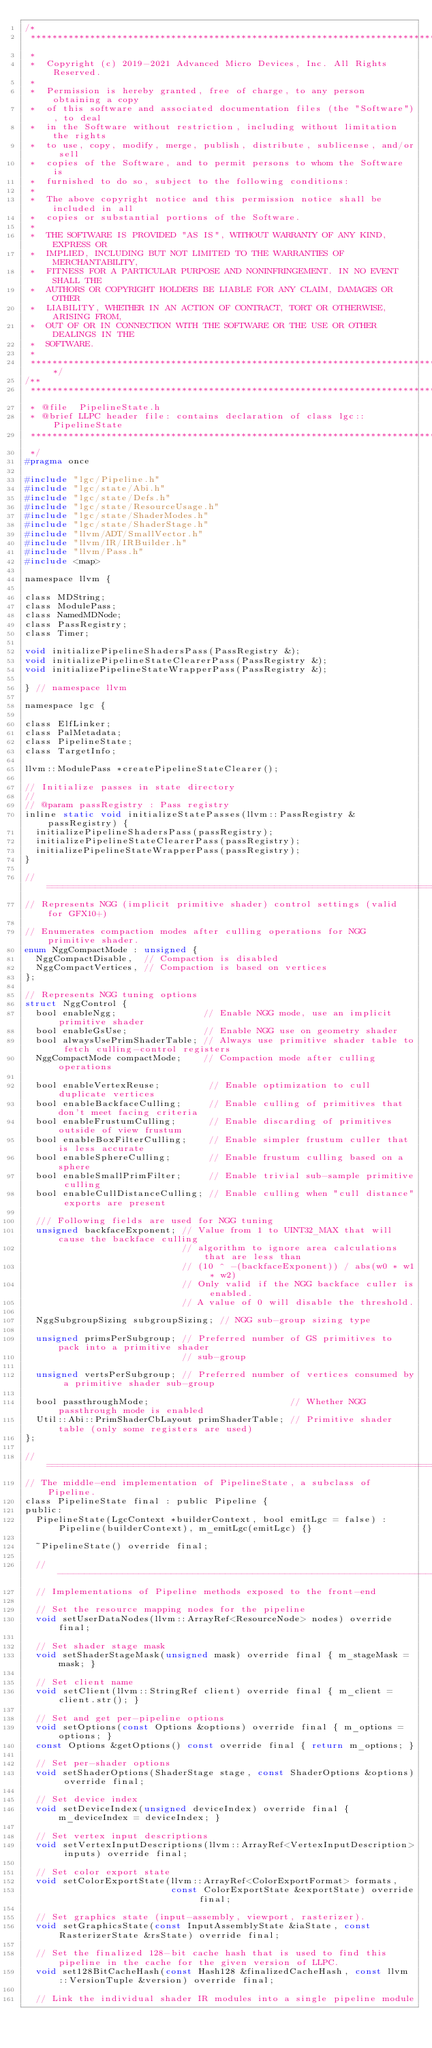<code> <loc_0><loc_0><loc_500><loc_500><_C_>/*
 ***********************************************************************************************************************
 *
 *  Copyright (c) 2019-2021 Advanced Micro Devices, Inc. All Rights Reserved.
 *
 *  Permission is hereby granted, free of charge, to any person obtaining a copy
 *  of this software and associated documentation files (the "Software"), to deal
 *  in the Software without restriction, including without limitation the rights
 *  to use, copy, modify, merge, publish, distribute, sublicense, and/or sell
 *  copies of the Software, and to permit persons to whom the Software is
 *  furnished to do so, subject to the following conditions:
 *
 *  The above copyright notice and this permission notice shall be included in all
 *  copies or substantial portions of the Software.
 *
 *  THE SOFTWARE IS PROVIDED "AS IS", WITHOUT WARRANTY OF ANY KIND, EXPRESS OR
 *  IMPLIED, INCLUDING BUT NOT LIMITED TO THE WARRANTIES OF MERCHANTABILITY,
 *  FITNESS FOR A PARTICULAR PURPOSE AND NONINFRINGEMENT. IN NO EVENT SHALL THE
 *  AUTHORS OR COPYRIGHT HOLDERS BE LIABLE FOR ANY CLAIM, DAMAGES OR OTHER
 *  LIABILITY, WHETHER IN AN ACTION OF CONTRACT, TORT OR OTHERWISE, ARISING FROM,
 *  OUT OF OR IN CONNECTION WITH THE SOFTWARE OR THE USE OR OTHER DEALINGS IN THE
 *  SOFTWARE.
 *
 **********************************************************************************************************************/
/**
 ***********************************************************************************************************************
 * @file  PipelineState.h
 * @brief LLPC header file: contains declaration of class lgc::PipelineState
 ***********************************************************************************************************************
 */
#pragma once

#include "lgc/Pipeline.h"
#include "lgc/state/Abi.h"
#include "lgc/state/Defs.h"
#include "lgc/state/ResourceUsage.h"
#include "lgc/state/ShaderModes.h"
#include "lgc/state/ShaderStage.h"
#include "llvm/ADT/SmallVector.h"
#include "llvm/IR/IRBuilder.h"
#include "llvm/Pass.h"
#include <map>

namespace llvm {

class MDString;
class ModulePass;
class NamedMDNode;
class PassRegistry;
class Timer;

void initializePipelineShadersPass(PassRegistry &);
void initializePipelineStateClearerPass(PassRegistry &);
void initializePipelineStateWrapperPass(PassRegistry &);

} // namespace llvm

namespace lgc {

class ElfLinker;
class PalMetadata;
class PipelineState;
class TargetInfo;

llvm::ModulePass *createPipelineStateClearer();

// Initialize passes in state directory
//
// @param passRegistry : Pass registry
inline static void initializeStatePasses(llvm::PassRegistry &passRegistry) {
  initializePipelineShadersPass(passRegistry);
  initializePipelineStateClearerPass(passRegistry);
  initializePipelineStateWrapperPass(passRegistry);
}

// =====================================================================================================================
// Represents NGG (implicit primitive shader) control settings (valid for GFX10+)

// Enumerates compaction modes after culling operations for NGG primitive shader.
enum NggCompactMode : unsigned {
  NggCompactDisable,  // Compaction is disabled
  NggCompactVertices, // Compaction is based on vertices
};

// Represents NGG tuning options
struct NggControl {
  bool enableNgg;                // Enable NGG mode, use an implicit primitive shader
  bool enableGsUse;              // Enable NGG use on geometry shader
  bool alwaysUsePrimShaderTable; // Always use primitive shader table to fetch culling-control registers
  NggCompactMode compactMode;    // Compaction mode after culling operations

  bool enableVertexReuse;         // Enable optimization to cull duplicate vertices
  bool enableBackfaceCulling;     // Enable culling of primitives that don't meet facing criteria
  bool enableFrustumCulling;      // Enable discarding of primitives outside of view frustum
  bool enableBoxFilterCulling;    // Enable simpler frustum culler that is less accurate
  bool enableSphereCulling;       // Enable frustum culling based on a sphere
  bool enableSmallPrimFilter;     // Enable trivial sub-sample primitive culling
  bool enableCullDistanceCulling; // Enable culling when "cull distance" exports are present

  /// Following fields are used for NGG tuning
  unsigned backfaceExponent; // Value from 1 to UINT32_MAX that will cause the backface culling
                             // algorithm to ignore area calculations that are less than
                             // (10 ^ -(backfaceExponent)) / abs(w0 * w1 * w2)
                             // Only valid if the NGG backface culler is enabled.
                             // A value of 0 will disable the threshold.

  NggSubgroupSizing subgroupSizing; // NGG sub-group sizing type

  unsigned primsPerSubgroup; // Preferred number of GS primitives to pack into a primitive shader
                             // sub-group

  unsigned vertsPerSubgroup; // Preferred number of vertices consumed by a primitive shader sub-group

  bool passthroughMode;                          // Whether NGG passthrough mode is enabled
  Util::Abi::PrimShaderCbLayout primShaderTable; // Primitive shader table (only some registers are used)
};

// =====================================================================================================================
// The middle-end implementation of PipelineState, a subclass of Pipeline.
class PipelineState final : public Pipeline {
public:
  PipelineState(LgcContext *builderContext, bool emitLgc = false) : Pipeline(builderContext), m_emitLgc(emitLgc) {}

  ~PipelineState() override final;

  // -----------------------------------------------------------------------------------------------------------------
  // Implementations of Pipeline methods exposed to the front-end

  // Set the resource mapping nodes for the pipeline
  void setUserDataNodes(llvm::ArrayRef<ResourceNode> nodes) override final;

  // Set shader stage mask
  void setShaderStageMask(unsigned mask) override final { m_stageMask = mask; }

  // Set client name
  void setClient(llvm::StringRef client) override final { m_client = client.str(); }

  // Set and get per-pipeline options
  void setOptions(const Options &options) override final { m_options = options; }
  const Options &getOptions() const override final { return m_options; }

  // Set per-shader options
  void setShaderOptions(ShaderStage stage, const ShaderOptions &options) override final;

  // Set device index
  void setDeviceIndex(unsigned deviceIndex) override final { m_deviceIndex = deviceIndex; }

  // Set vertex input descriptions
  void setVertexInputDescriptions(llvm::ArrayRef<VertexInputDescription> inputs) override final;

  // Set color export state
  void setColorExportState(llvm::ArrayRef<ColorExportFormat> formats,
                           const ColorExportState &exportState) override final;

  // Set graphics state (input-assembly, viewport, rasterizer).
  void setGraphicsState(const InputAssemblyState &iaState, const RasterizerState &rsState) override final;

  // Set the finalized 128-bit cache hash that is used to find this pipeline in the cache for the given version of LLPC.
  void set128BitCacheHash(const Hash128 &finalizedCacheHash, const llvm::VersionTuple &version) override final;

  // Link the individual shader IR modules into a single pipeline module</code> 